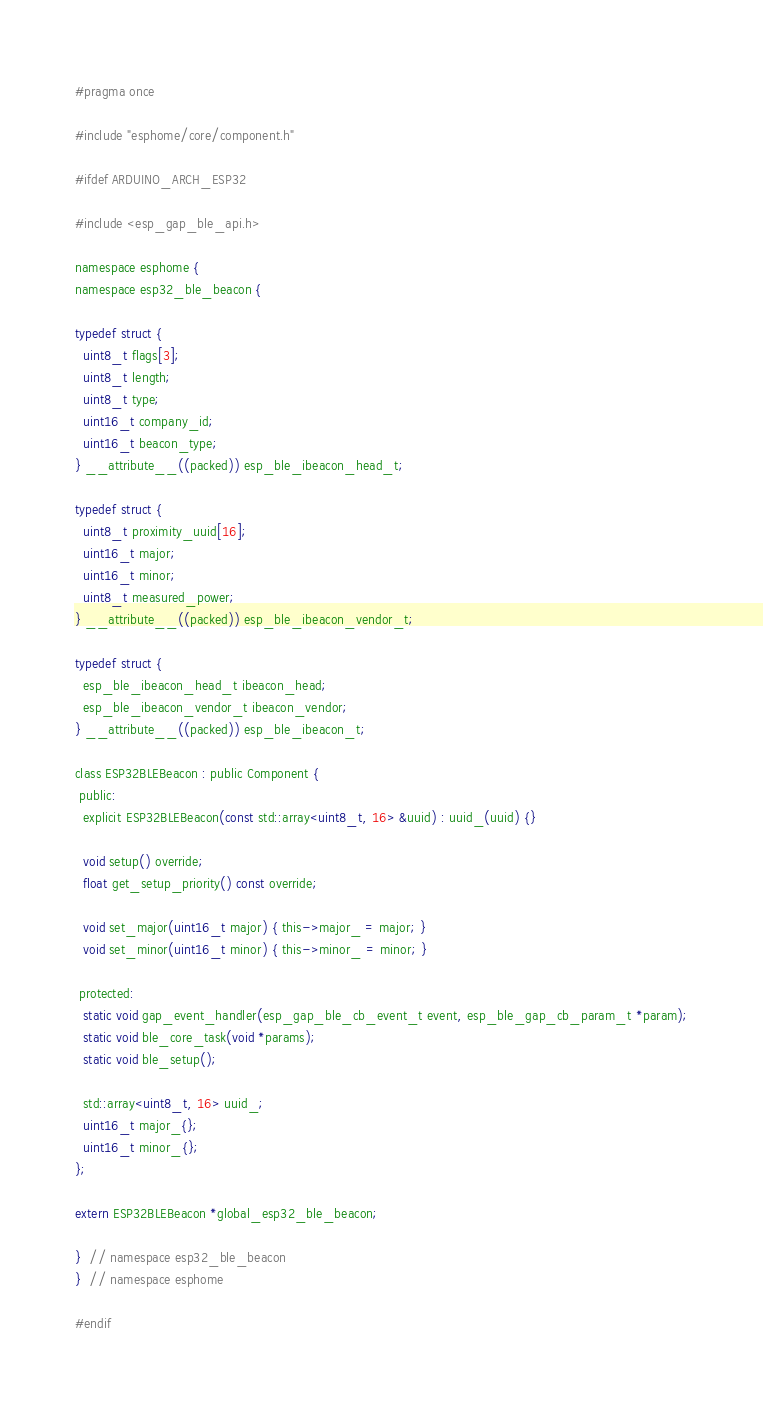<code> <loc_0><loc_0><loc_500><loc_500><_C_>#pragma once

#include "esphome/core/component.h"

#ifdef ARDUINO_ARCH_ESP32

#include <esp_gap_ble_api.h>

namespace esphome {
namespace esp32_ble_beacon {

typedef struct {
  uint8_t flags[3];
  uint8_t length;
  uint8_t type;
  uint16_t company_id;
  uint16_t beacon_type;
} __attribute__((packed)) esp_ble_ibeacon_head_t;

typedef struct {
  uint8_t proximity_uuid[16];
  uint16_t major;
  uint16_t minor;
  uint8_t measured_power;
} __attribute__((packed)) esp_ble_ibeacon_vendor_t;

typedef struct {
  esp_ble_ibeacon_head_t ibeacon_head;
  esp_ble_ibeacon_vendor_t ibeacon_vendor;
} __attribute__((packed)) esp_ble_ibeacon_t;

class ESP32BLEBeacon : public Component {
 public:
  explicit ESP32BLEBeacon(const std::array<uint8_t, 16> &uuid) : uuid_(uuid) {}

  void setup() override;
  float get_setup_priority() const override;

  void set_major(uint16_t major) { this->major_ = major; }
  void set_minor(uint16_t minor) { this->minor_ = minor; }

 protected:
  static void gap_event_handler(esp_gap_ble_cb_event_t event, esp_ble_gap_cb_param_t *param);
  static void ble_core_task(void *params);
  static void ble_setup();

  std::array<uint8_t, 16> uuid_;
  uint16_t major_{};
  uint16_t minor_{};
};

extern ESP32BLEBeacon *global_esp32_ble_beacon;

}  // namespace esp32_ble_beacon
}  // namespace esphome

#endif
</code> 